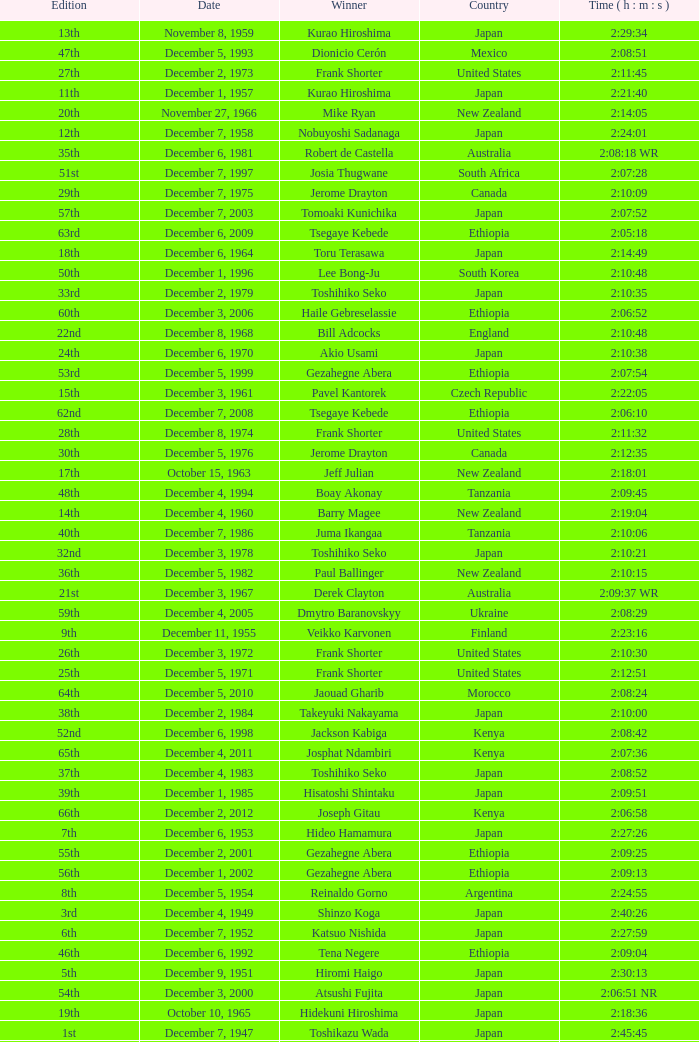Would you be able to parse every entry in this table? {'header': ['Edition', 'Date', 'Winner', 'Country', 'Time ( h : m : s )'], 'rows': [['13th', 'November 8, 1959', 'Kurao Hiroshima', 'Japan', '2:29:34'], ['47th', 'December 5, 1993', 'Dionicio Cerón', 'Mexico', '2:08:51'], ['27th', 'December 2, 1973', 'Frank Shorter', 'United States', '2:11:45'], ['11th', 'December 1, 1957', 'Kurao Hiroshima', 'Japan', '2:21:40'], ['20th', 'November 27, 1966', 'Mike Ryan', 'New Zealand', '2:14:05'], ['12th', 'December 7, 1958', 'Nobuyoshi Sadanaga', 'Japan', '2:24:01'], ['35th', 'December 6, 1981', 'Robert de Castella', 'Australia', '2:08:18 WR'], ['51st', 'December 7, 1997', 'Josia Thugwane', 'South Africa', '2:07:28'], ['29th', 'December 7, 1975', 'Jerome Drayton', 'Canada', '2:10:09'], ['57th', 'December 7, 2003', 'Tomoaki Kunichika', 'Japan', '2:07:52'], ['63rd', 'December 6, 2009', 'Tsegaye Kebede', 'Ethiopia', '2:05:18'], ['18th', 'December 6, 1964', 'Toru Terasawa', 'Japan', '2:14:49'], ['50th', 'December 1, 1996', 'Lee Bong-Ju', 'South Korea', '2:10:48'], ['33rd', 'December 2, 1979', 'Toshihiko Seko', 'Japan', '2:10:35'], ['60th', 'December 3, 2006', 'Haile Gebreselassie', 'Ethiopia', '2:06:52'], ['22nd', 'December 8, 1968', 'Bill Adcocks', 'England', '2:10:48'], ['24th', 'December 6, 1970', 'Akio Usami', 'Japan', '2:10:38'], ['53rd', 'December 5, 1999', 'Gezahegne Abera', 'Ethiopia', '2:07:54'], ['15th', 'December 3, 1961', 'Pavel Kantorek', 'Czech Republic', '2:22:05'], ['62nd', 'December 7, 2008', 'Tsegaye Kebede', 'Ethiopia', '2:06:10'], ['28th', 'December 8, 1974', 'Frank Shorter', 'United States', '2:11:32'], ['30th', 'December 5, 1976', 'Jerome Drayton', 'Canada', '2:12:35'], ['17th', 'October 15, 1963', 'Jeff Julian', 'New Zealand', '2:18:01'], ['48th', 'December 4, 1994', 'Boay Akonay', 'Tanzania', '2:09:45'], ['14th', 'December 4, 1960', 'Barry Magee', 'New Zealand', '2:19:04'], ['40th', 'December 7, 1986', 'Juma Ikangaa', 'Tanzania', '2:10:06'], ['32nd', 'December 3, 1978', 'Toshihiko Seko', 'Japan', '2:10:21'], ['36th', 'December 5, 1982', 'Paul Ballinger', 'New Zealand', '2:10:15'], ['21st', 'December 3, 1967', 'Derek Clayton', 'Australia', '2:09:37 WR'], ['59th', 'December 4, 2005', 'Dmytro Baranovskyy', 'Ukraine', '2:08:29'], ['9th', 'December 11, 1955', 'Veikko Karvonen', 'Finland', '2:23:16'], ['26th', 'December 3, 1972', 'Frank Shorter', 'United States', '2:10:30'], ['25th', 'December 5, 1971', 'Frank Shorter', 'United States', '2:12:51'], ['64th', 'December 5, 2010', 'Jaouad Gharib', 'Morocco', '2:08:24'], ['38th', 'December 2, 1984', 'Takeyuki Nakayama', 'Japan', '2:10:00'], ['52nd', 'December 6, 1998', 'Jackson Kabiga', 'Kenya', '2:08:42'], ['65th', 'December 4, 2011', 'Josphat Ndambiri', 'Kenya', '2:07:36'], ['37th', 'December 4, 1983', 'Toshihiko Seko', 'Japan', '2:08:52'], ['39th', 'December 1, 1985', 'Hisatoshi Shintaku', 'Japan', '2:09:51'], ['66th', 'December 2, 2012', 'Joseph Gitau', 'Kenya', '2:06:58'], ['7th', 'December 6, 1953', 'Hideo Hamamura', 'Japan', '2:27:26'], ['55th', 'December 2, 2001', 'Gezahegne Abera', 'Ethiopia', '2:09:25'], ['56th', 'December 1, 2002', 'Gezahegne Abera', 'Ethiopia', '2:09:13'], ['8th', 'December 5, 1954', 'Reinaldo Gorno', 'Argentina', '2:24:55'], ['3rd', 'December 4, 1949', 'Shinzo Koga', 'Japan', '2:40:26'], ['6th', 'December 7, 1952', 'Katsuo Nishida', 'Japan', '2:27:59'], ['46th', 'December 6, 1992', 'Tena Negere', 'Ethiopia', '2:09:04'], ['5th', 'December 9, 1951', 'Hiromi Haigo', 'Japan', '2:30:13'], ['54th', 'December 3, 2000', 'Atsushi Fujita', 'Japan', '2:06:51 NR'], ['19th', 'October 10, 1965', 'Hidekuni Hiroshima', 'Japan', '2:18:36'], ['1st', 'December 7, 1947', 'Toshikazu Wada', 'Japan', '2:45:45'], ['42nd', 'December 4, 1988', 'Toshihiro Shibutani', 'Japan', '2:11:04'], ['49th', 'December 3, 1995', 'Luiz Antonio dos Santos', 'Brazil', '2:09:30'], ['43rd', 'December 3, 1989', 'Manuel Matias', 'Portugal', '2:12:54'], ['16th', 'December 2, 1962', 'Toru Terasawa', 'Japan', '2:16:19'], ['4th', 'December 10, 1950', 'Shunji Koyanagi', 'Japan', '2:30:47'], ['58th', 'December 5, 2004', 'Tsuyoshi Ogata', 'Japan', '2:09:10'], ['10th', 'December 9, 1956', 'Keizo Yamada', 'Japan', '2:25:15'], ['61st', 'December 2, 2007', 'Samuel Wanjiru', 'Kenya', '2:06:39'], ['41st', 'December 6, 1987', 'Takeyuki Nakayama', 'Japan', '2:08:18'], ['31st', 'December 4, 1977', 'Bill Rodgers', 'United States', '2:10:56'], ['2nd', 'December 5, 1948', 'Saburo Yamada', 'Japan', '2:37:25'], ['23rd', 'December 7, 1969', 'Jerome Drayton', 'Canada', '2:11:13'], ['34th', 'December 7, 1980', 'Toshihiko Seko', 'Japan', '2:09:45'], ['44th', 'December 2, 1990', 'Belayneh Densamo', 'Ethiopia', '2:11:35'], ['45th', 'December 1, 1991', 'Shuichi Morita', 'Japan', '2:10:58']]} What was the nationality of the winner on December 8, 1968? England. 